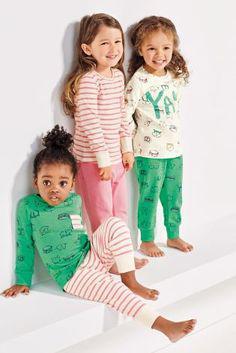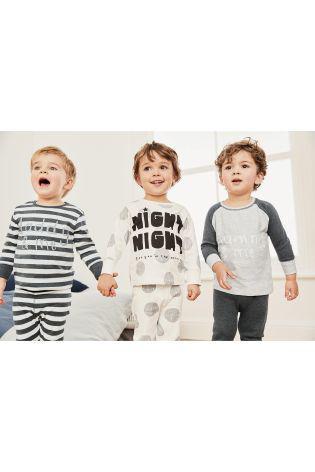The first image is the image on the left, the second image is the image on the right. For the images displayed, is the sentence "the left image has the middle child sitting criss cross" factually correct? Answer yes or no. No. The first image is the image on the left, the second image is the image on the right. For the images shown, is this caption "There is a boy wearing pajamas in the center of each image." true? Answer yes or no. No. 